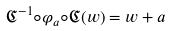Convert formula to latex. <formula><loc_0><loc_0><loc_500><loc_500>\mathfrak { C } ^ { - 1 } \circ \varphi _ { a } \circ \mathfrak { C } ( w ) = w + a</formula> 